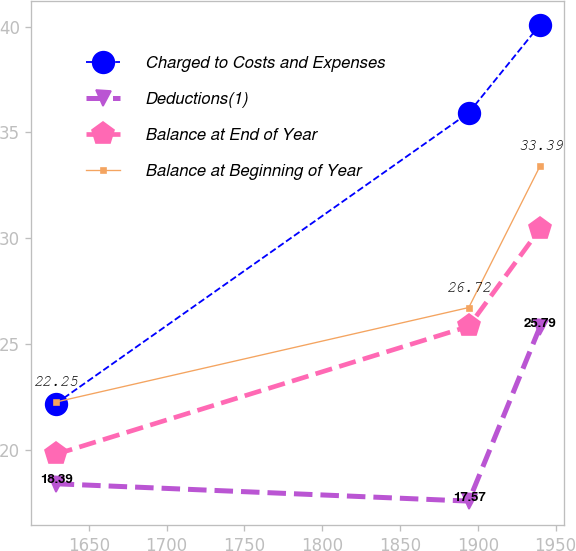Convert chart. <chart><loc_0><loc_0><loc_500><loc_500><line_chart><ecel><fcel>Charged to Costs and Expenses<fcel>Deductions(1)<fcel>Balance at End of Year<fcel>Balance at Beginning of Year<nl><fcel>1628.75<fcel>22.17<fcel>18.39<fcel>19.78<fcel>22.25<nl><fcel>1894.25<fcel>35.93<fcel>17.57<fcel>25.83<fcel>26.72<nl><fcel>1939.93<fcel>40.08<fcel>25.79<fcel>30.43<fcel>33.39<nl></chart> 